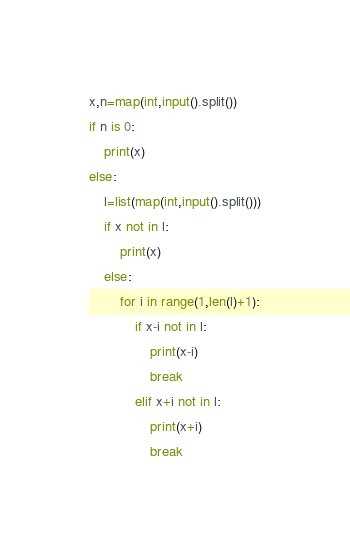Convert code to text. <code><loc_0><loc_0><loc_500><loc_500><_Python_>x,n=map(int,input().split())
if n is 0:
    print(x)   
else:
    l=list(map(int,input().split()))
    if x not in l:
        print(x)
    else:
        for i in range(1,len(l)+1):
            if x-i not in l:
                print(x-i)
                break
            elif x+i not in l:
                print(x+i)
                break</code> 